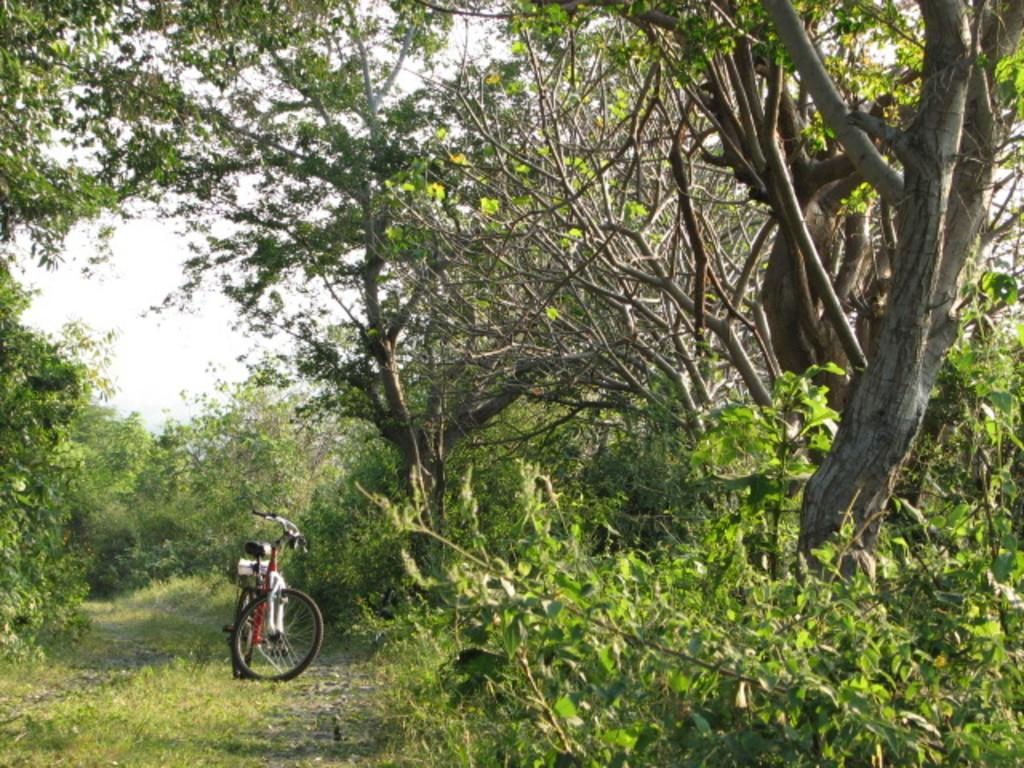What is the main object in the image? There is a bicycle in the image. What type of natural environment is depicted in the image? There are trees and grass in the image, suggesting a natural setting. What can be seen in the background of the image? The sky and plants are visible in the background of the image. What type of art is displayed on the page in the image? There is no page or art present in the image; it features a bicycle, trees, grass, and the sky in the background. 